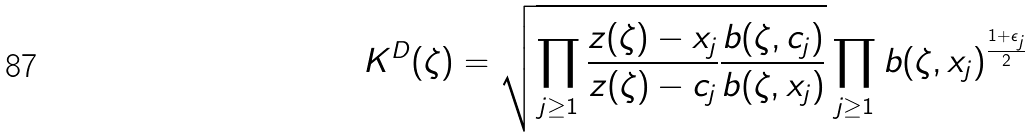<formula> <loc_0><loc_0><loc_500><loc_500>K ^ { D } ( \zeta ) = \sqrt { \prod _ { j \geq 1 } \frac { z ( \zeta ) - x _ { j } } { z ( \zeta ) - c _ { j } } \frac { b ( \zeta , c _ { j } ) } { b ( \zeta , x _ { j } ) } } \prod _ { j \geq 1 } b ( \zeta , x _ { j } ) ^ { \frac { 1 + \epsilon _ { j } } { 2 } }</formula> 